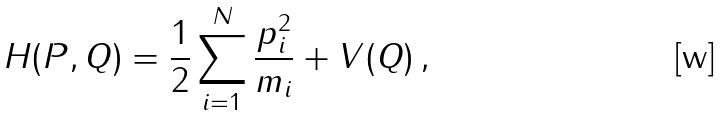Convert formula to latex. <formula><loc_0><loc_0><loc_500><loc_500>H ( P , Q ) = \frac { 1 } { 2 } \sum _ { i = 1 } ^ { N } \frac { p _ { i } ^ { 2 } } { m _ { i } } + V ( Q ) \, ,</formula> 